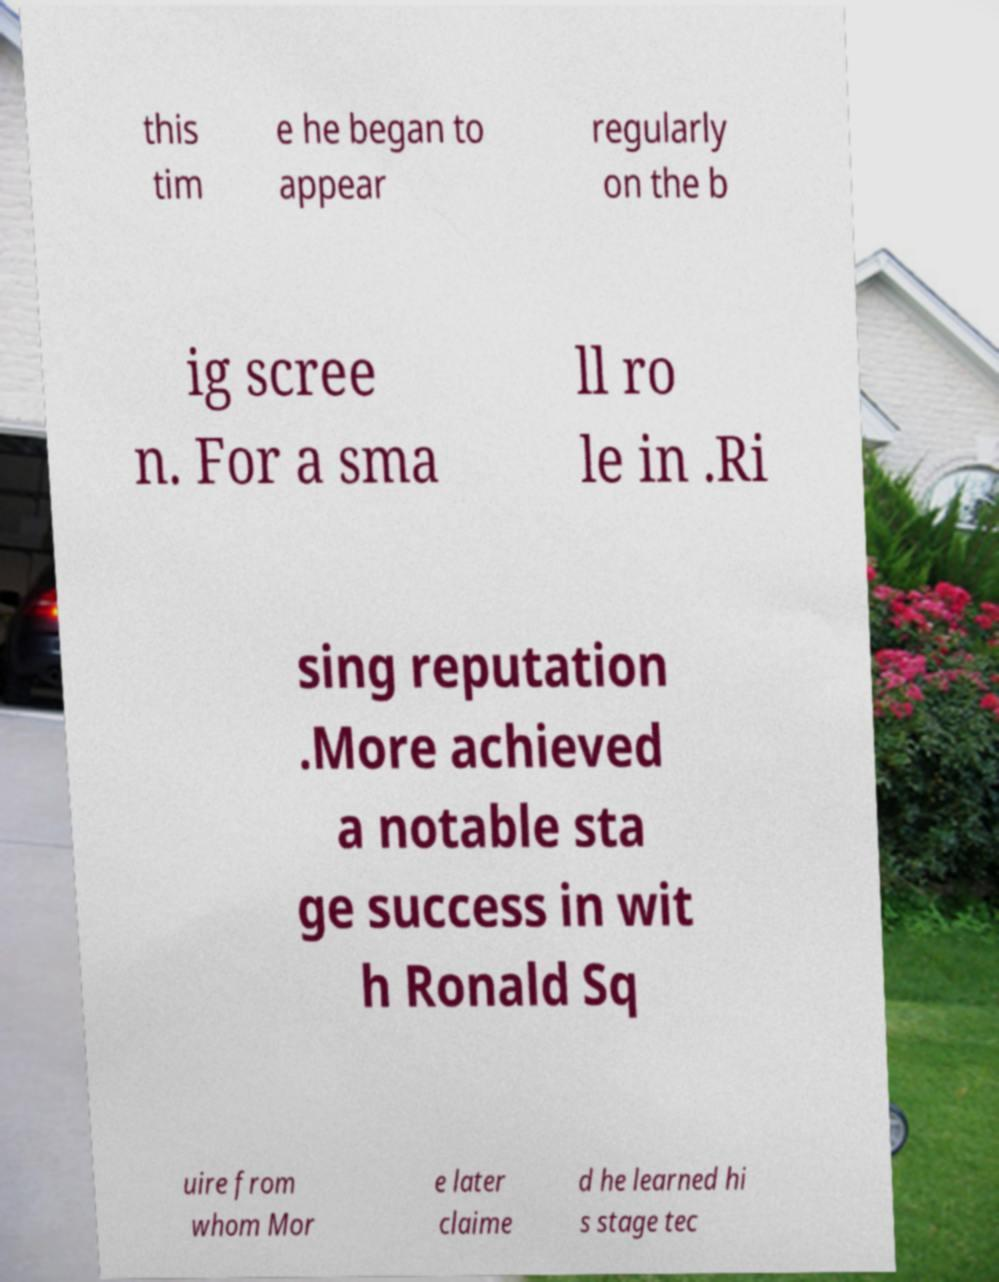Could you extract and type out the text from this image? this tim e he began to appear regularly on the b ig scree n. For a sma ll ro le in .Ri sing reputation .More achieved a notable sta ge success in wit h Ronald Sq uire from whom Mor e later claime d he learned hi s stage tec 